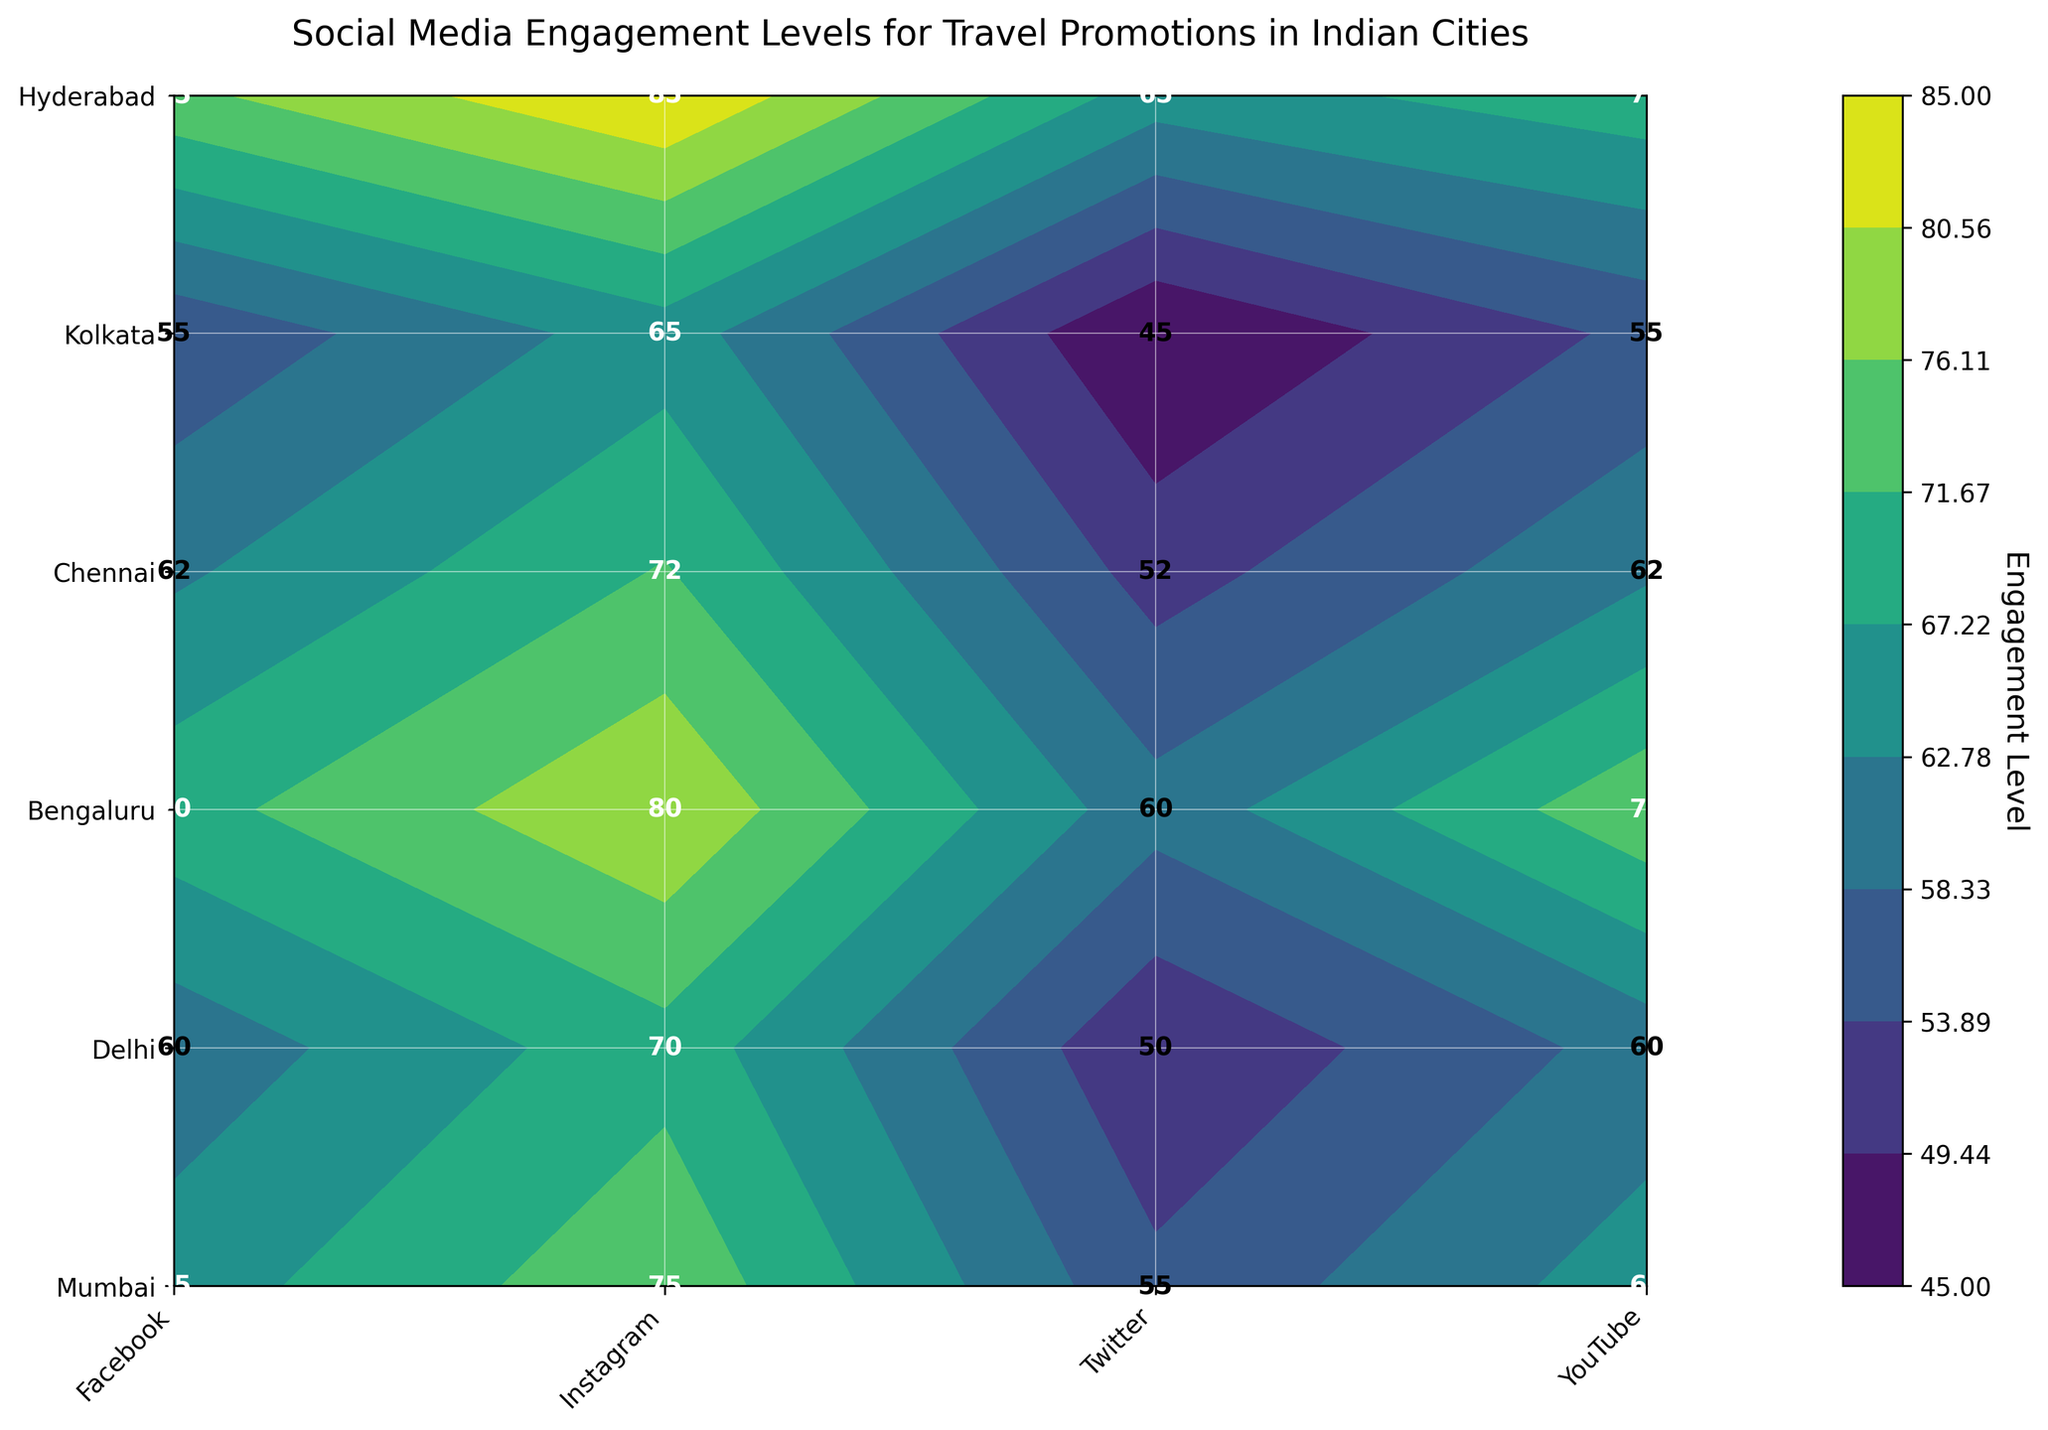What's the title of the figure? The title of the figure is displayed at the top of the plot, indicating what the figure represents.
Answer: Social Media Engagement Levels for Travel Promotions in Indian Cities Which city has the highest overall engagement level on Instagram? By looking at the contour plot and the label values, we identify that Mumbai has the highest engagement level on Instagram with a value of 85.
Answer: Mumbai How many platforms are presented in the figure? The x-axis displays the platforms. By counting the tick marks, we can determine there are four platforms: Facebook, Instagram, Twitter, and YouTube.
Answer: Four Which platform has the lowest engagement level in Kolkata? To find this, we look at the labels for Kolkata and note the lowest value. In Kolkata, Twitter has the lowest engagement level with a value of 45.
Answer: Twitter What's the average engagement level of YouTube across all cities? First, locate the engagement levels for YouTube: Mumbai (70), Delhi (75), Bengaluru (65), Chennai (60), Kolkata (55), Hyderabad (62). Sum these values 70 + 75 + 65 + 60 + 55 + 62 = 387, then divide by the number of cities (6). The average is 387 / 6 = 64.5.
Answer: 64.5 Which city shows the greatest variation in engagement levels across different platforms? By comparing the highest and lowest values for each city, Mumbai has the greatest variation: 85 (Instagram) - 65 (Twitter) = 20.
Answer: Mumbai What is the engagement level for Twitter in Delhi? Locate Delhi on the y-axis and follow it to where it intersects with Twitter on the x-axis to find the labeled engagement level, which is 60.
Answer: 60 What is the combined engagement level of Instagram for Bengaluru and Chennai? Find the engagement levels for Instagram in Bengaluru (75) and Chennai (70), then sum them up: 75 + 70 = 145.
Answer: 145 Which platform has the highest average engagement level across all cities? Find the average for each platform: 
  - Facebook: (75 + 70 + 65 + 60 + 55 + 62) / 6 = 64.5 
  - Instagram: (85 + 80 + 75 + 70 + 65 + 72) / 6 = 74.5 
  - Twitter: (65 + 60 + 55 + 50 + 45 + 52) / 6 = 54.5 
  - YouTube: (70 + 75 + 65 + 60 + 55 + 62) / 6 = 64.5 
  Instagram has the highest average engagement level.
Answer: Instagram Which combination of city and platform has the lowest engagement level? By inspecting all the labels on the contour plot, we find that Twitter in Kolkata has the lowest engagement level with a value of 45.
Answer: Kolkata, Twitter 